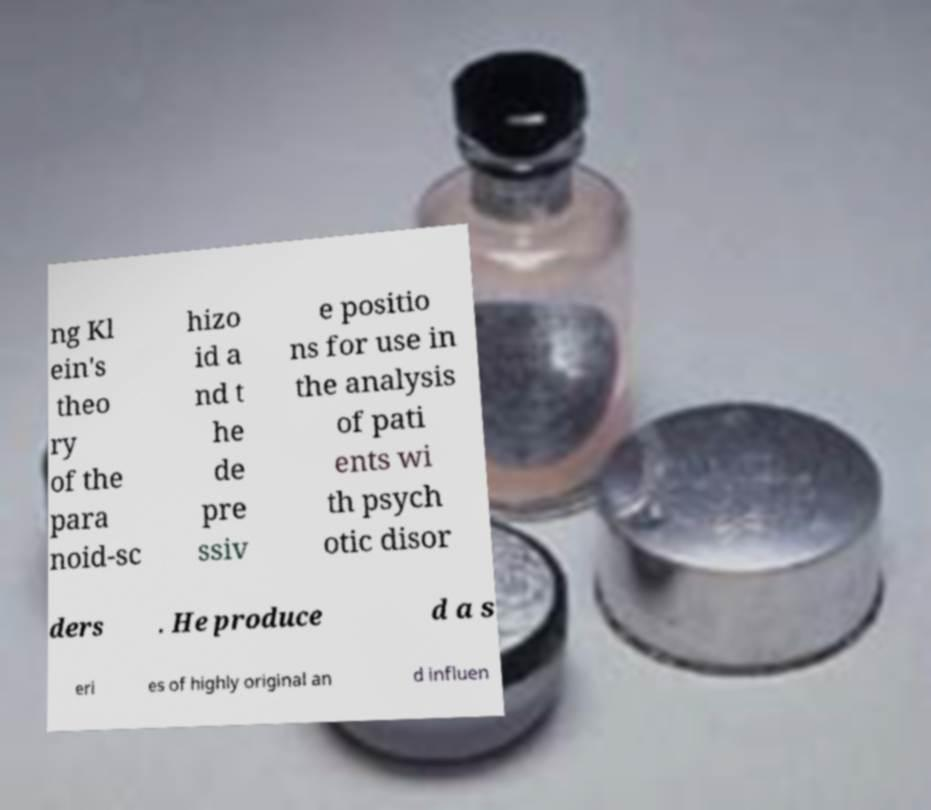I need the written content from this picture converted into text. Can you do that? ng Kl ein's theo ry of the para noid-sc hizo id a nd t he de pre ssiv e positio ns for use in the analysis of pati ents wi th psych otic disor ders . He produce d a s eri es of highly original an d influen 